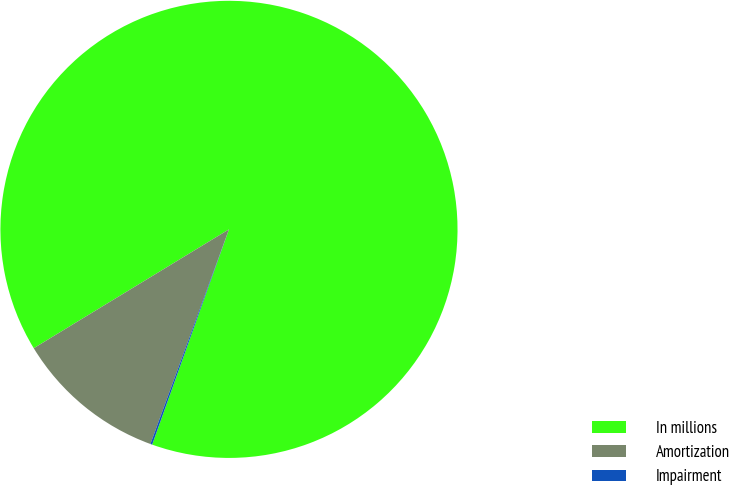<chart> <loc_0><loc_0><loc_500><loc_500><pie_chart><fcel>In millions<fcel>Amortization<fcel>Impairment<nl><fcel>89.15%<fcel>10.71%<fcel>0.13%<nl></chart> 